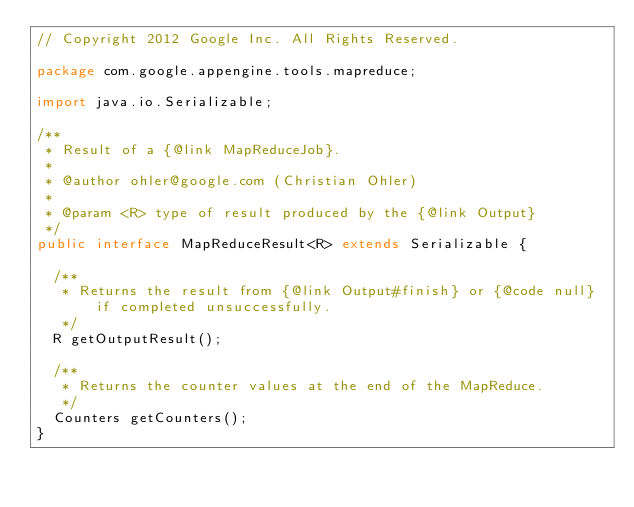<code> <loc_0><loc_0><loc_500><loc_500><_Java_>// Copyright 2012 Google Inc. All Rights Reserved.

package com.google.appengine.tools.mapreduce;

import java.io.Serializable;

/**
 * Result of a {@link MapReduceJob}.
 *
 * @author ohler@google.com (Christian Ohler)
 *
 * @param <R> type of result produced by the {@link Output}
 */
public interface MapReduceResult<R> extends Serializable {

  /**
   * Returns the result from {@link Output#finish} or {@code null} if completed unsuccessfully.
   */
  R getOutputResult();

  /**
   * Returns the counter values at the end of the MapReduce.
   */
  Counters getCounters();
}
</code> 